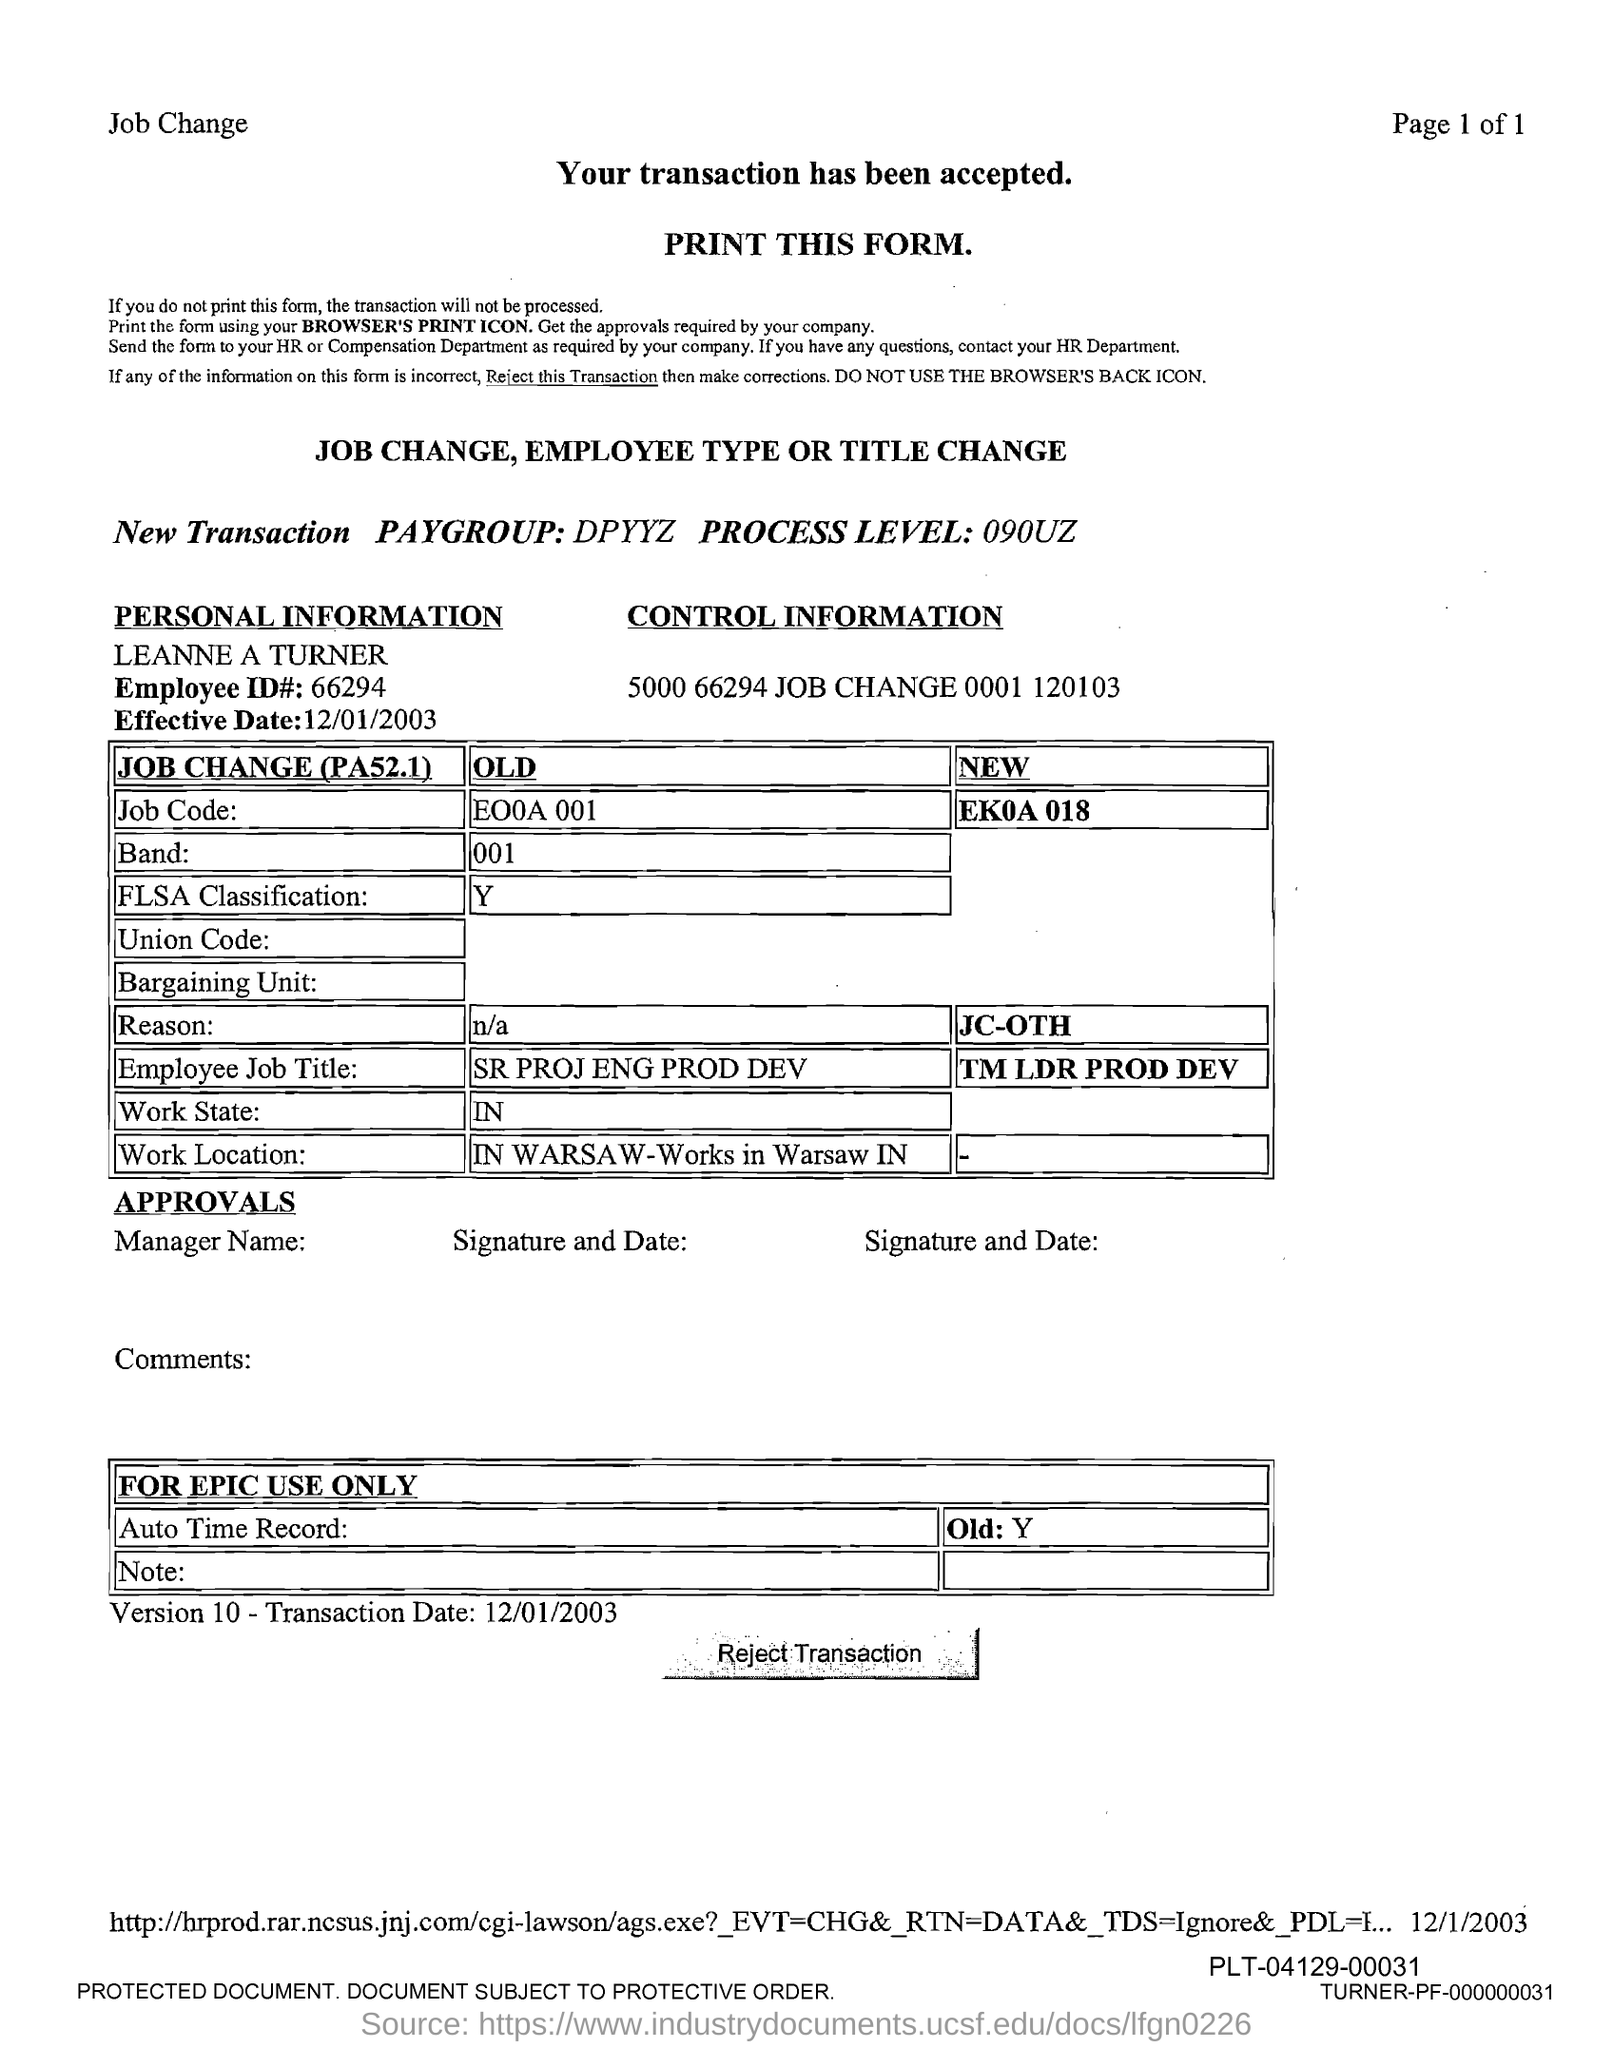Outline some significant characteristics in this image. The employee ID is 66294... 